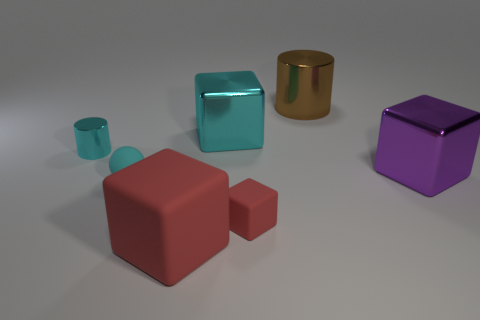Add 2 small green objects. How many objects exist? 9 Subtract all spheres. How many objects are left? 6 Add 2 small red blocks. How many small red blocks exist? 3 Subtract 0 green spheres. How many objects are left? 7 Subtract all big gray rubber blocks. Subtract all purple metal things. How many objects are left? 6 Add 2 small cubes. How many small cubes are left? 3 